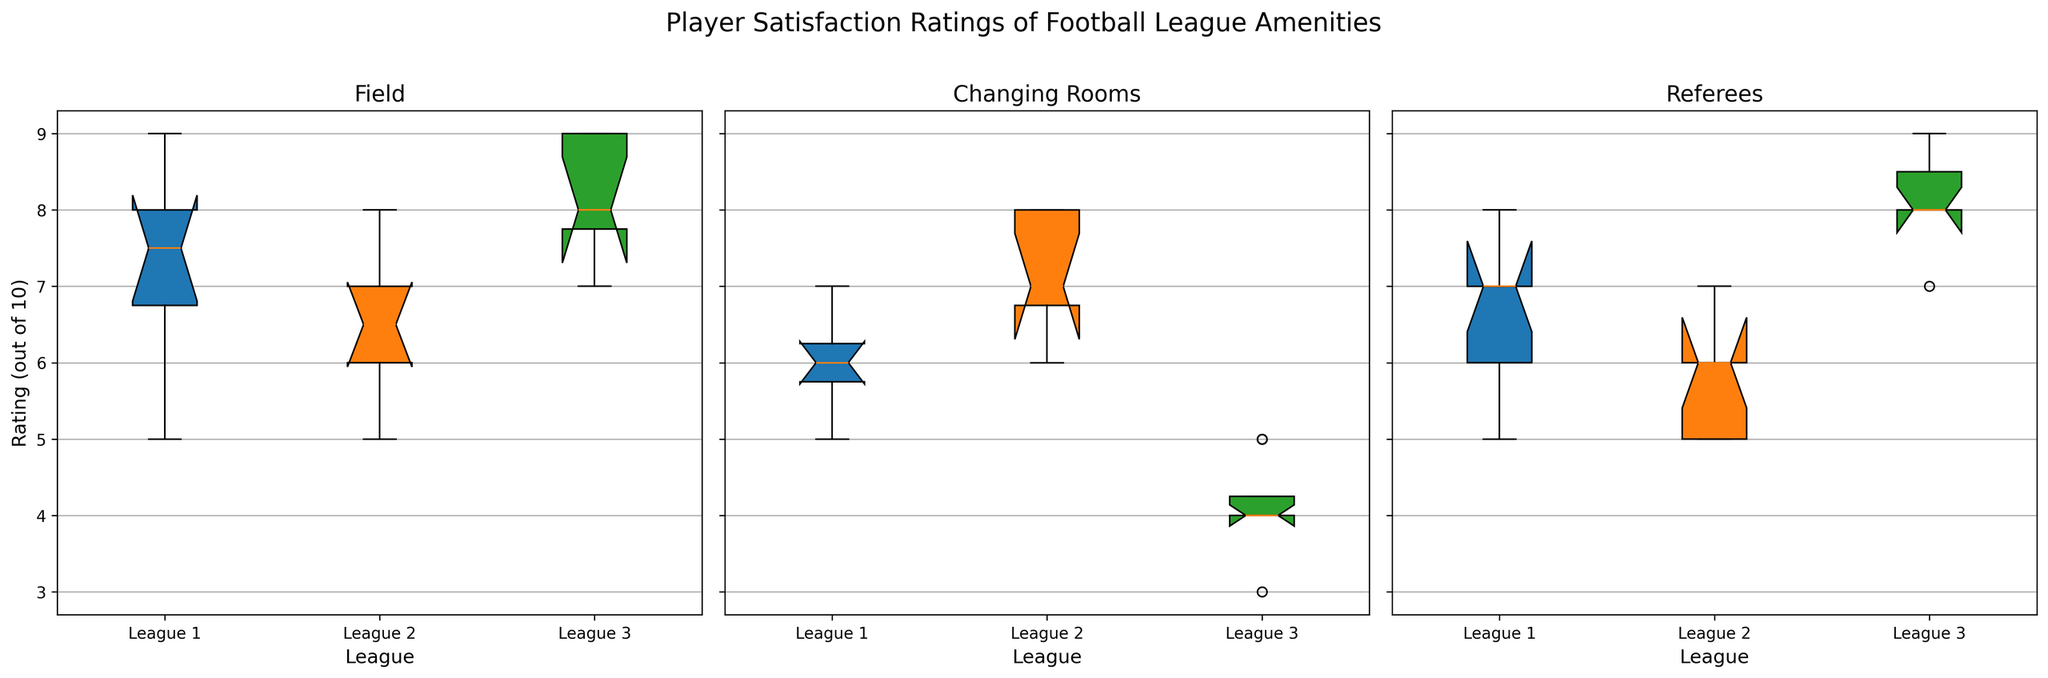What is the median satisfaction rating for fields in League 1? To find the median, arrange the ratings in ascending order: 5, 6, 7, 7, 7, 8, 8, 8, 9. The middle value (5th value) is 7.
Answer: 7 Which amenity had the lowest median rating in League 3? For League 3, arrange the ratings for each amenity. For Fields: 7, 7, 8, 8, 8, 9, 9, 9 (median is 8). For Changing Rooms: 3, 4, 4, 4, 4, 5, 5 (median is 4). For Referees: 7, 8, 8, 8, 8, 9, 9 (median is 8). The lowest median (4) is for Changing Rooms.
Answer: Changing Rooms Which league has the highest median rating for referees? Check the median ratings for referees: League 1: 5, 6, 6, 6, 7, 7, 7, 8 (median is 6.5). League 2: 5, 5, 5, 6, 6, 6, 7 (median is 6). League 3: 7, 8, 8, 8, 8, 9, 9 (median is 8). League 3 has the highest median rating (8).
Answer: League 3 Which league has the largest interquartile range (IQR) for field ratings? Calculate IQR for each league: League 1: Q1=6, Med=7, Q3=8, IQR=8-6=2. League 2: Q1=6, Med=6.5, Q3=7, IQR=7-6=1. League 3: Q1=7, Med=8, Q3=9, IQR=9-7=2. League 1 and League 3 both have the largest IQR (2).
Answer: League 1 and League 3 Which amenity shows the most variability in ratings across all leagues? The variability can be observed from the spread of the box plots (range of values). Referees in League 3 and Fields in League 1 show significant variability, but Changing Rooms in League 3 has the widest range (3 to 5), indicating the most variability.
Answer: Changing Rooms 